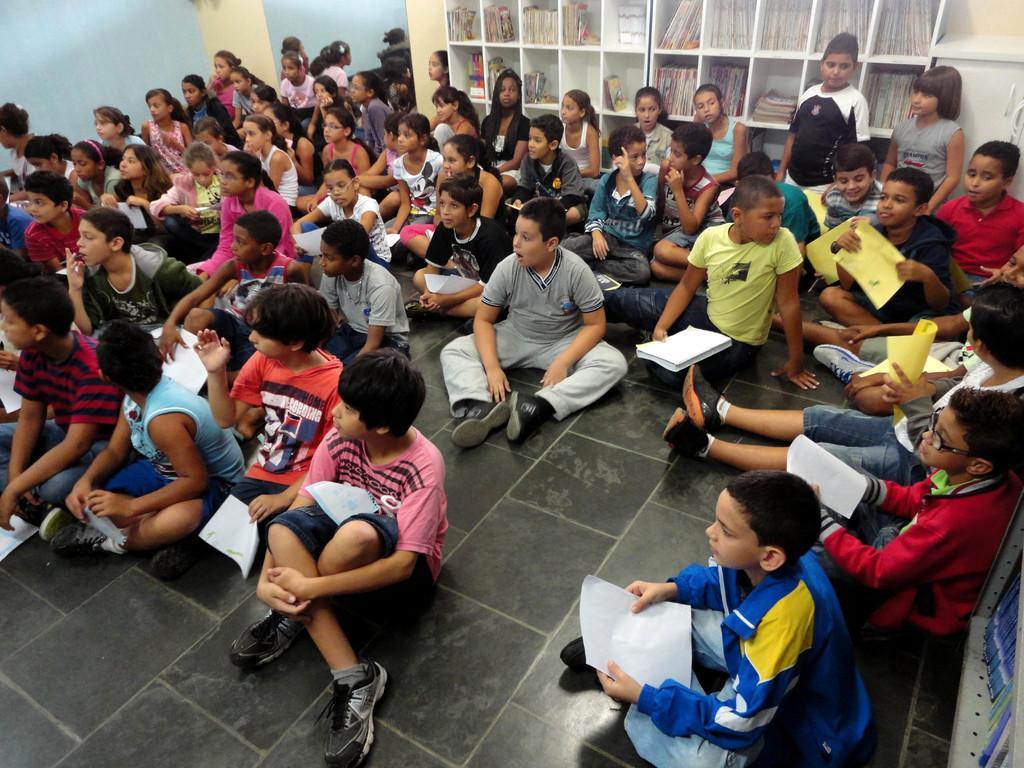Could you give a brief overview of what you see in this image? In this image we can see a group of children sitting on the floor. In that some are holding the papers. On the backside we can see a group of books placed in the shelves. We can also see a container and a wall. At the bottom right we can see some books placed in a rack. 